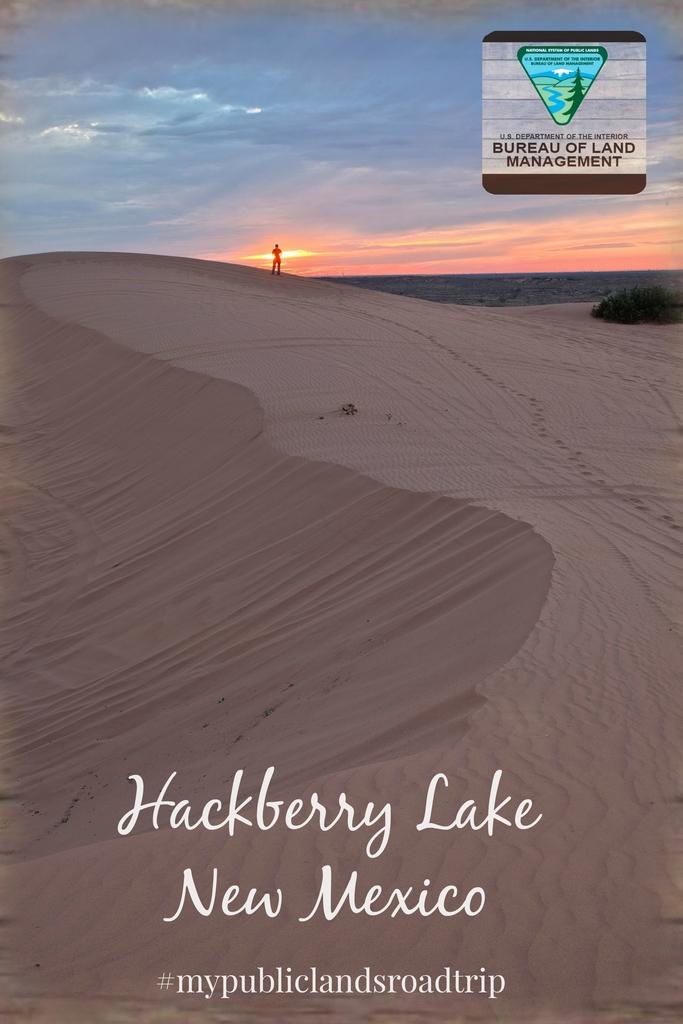Where is hackberry lake?
Keep it short and to the point. New mexico. What is the hashtag on the bottom of the image?
Provide a short and direct response. #mypubliclandsroadtrip. 